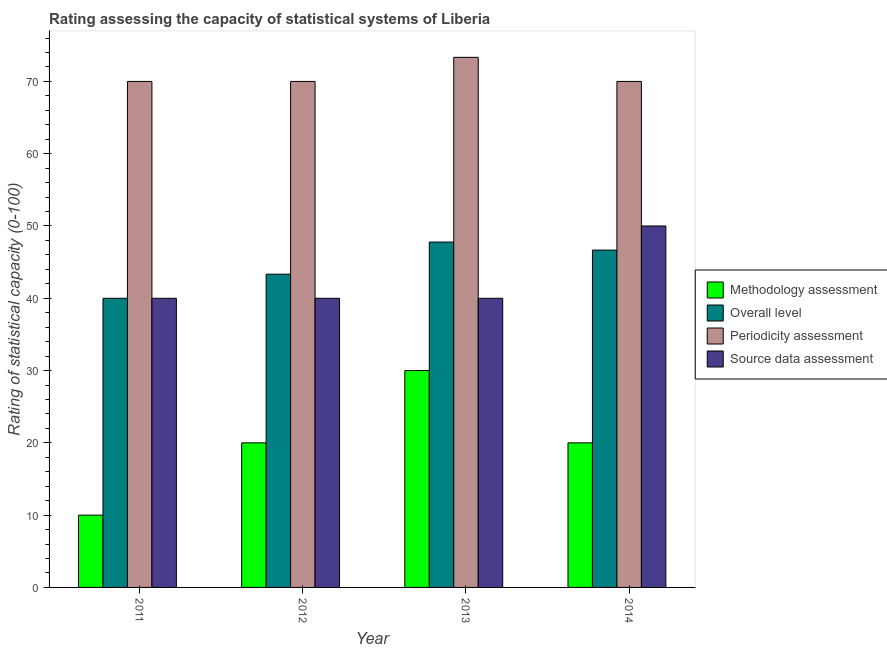How many different coloured bars are there?
Keep it short and to the point. 4. Are the number of bars per tick equal to the number of legend labels?
Keep it short and to the point. Yes. Are the number of bars on each tick of the X-axis equal?
Offer a very short reply. Yes. How many bars are there on the 3rd tick from the left?
Your answer should be very brief. 4. What is the label of the 4th group of bars from the left?
Make the answer very short. 2014. In how many cases, is the number of bars for a given year not equal to the number of legend labels?
Provide a short and direct response. 0. What is the source data assessment rating in 2012?
Your answer should be compact. 40. Across all years, what is the maximum overall level rating?
Keep it short and to the point. 47.78. Across all years, what is the minimum periodicity assessment rating?
Your response must be concise. 70. In which year was the source data assessment rating minimum?
Offer a very short reply. 2011. What is the total periodicity assessment rating in the graph?
Make the answer very short. 283.33. What is the difference between the methodology assessment rating in 2013 and the overall level rating in 2011?
Your answer should be compact. 20. In how many years, is the periodicity assessment rating greater than 6?
Make the answer very short. 4. What is the ratio of the source data assessment rating in 2012 to that in 2013?
Provide a succinct answer. 1. Is the source data assessment rating in 2013 less than that in 2014?
Your response must be concise. Yes. What is the difference between the highest and the second highest methodology assessment rating?
Your answer should be compact. 10. What is the difference between the highest and the lowest methodology assessment rating?
Offer a terse response. 20. In how many years, is the overall level rating greater than the average overall level rating taken over all years?
Provide a short and direct response. 2. Is the sum of the periodicity assessment rating in 2012 and 2014 greater than the maximum source data assessment rating across all years?
Your response must be concise. Yes. Is it the case that in every year, the sum of the source data assessment rating and methodology assessment rating is greater than the sum of periodicity assessment rating and overall level rating?
Provide a short and direct response. No. What does the 4th bar from the left in 2014 represents?
Ensure brevity in your answer.  Source data assessment. What does the 2nd bar from the right in 2012 represents?
Provide a short and direct response. Periodicity assessment. How many bars are there?
Make the answer very short. 16. What is the difference between two consecutive major ticks on the Y-axis?
Offer a terse response. 10. Are the values on the major ticks of Y-axis written in scientific E-notation?
Provide a short and direct response. No. How many legend labels are there?
Ensure brevity in your answer.  4. What is the title of the graph?
Make the answer very short. Rating assessing the capacity of statistical systems of Liberia. Does "Rule based governance" appear as one of the legend labels in the graph?
Provide a succinct answer. No. What is the label or title of the Y-axis?
Keep it short and to the point. Rating of statistical capacity (0-100). What is the Rating of statistical capacity (0-100) of Overall level in 2011?
Make the answer very short. 40. What is the Rating of statistical capacity (0-100) in Periodicity assessment in 2011?
Your response must be concise. 70. What is the Rating of statistical capacity (0-100) of Source data assessment in 2011?
Give a very brief answer. 40. What is the Rating of statistical capacity (0-100) in Overall level in 2012?
Your answer should be very brief. 43.33. What is the Rating of statistical capacity (0-100) of Periodicity assessment in 2012?
Provide a short and direct response. 70. What is the Rating of statistical capacity (0-100) of Overall level in 2013?
Ensure brevity in your answer.  47.78. What is the Rating of statistical capacity (0-100) in Periodicity assessment in 2013?
Make the answer very short. 73.33. What is the Rating of statistical capacity (0-100) of Methodology assessment in 2014?
Make the answer very short. 20. What is the Rating of statistical capacity (0-100) in Overall level in 2014?
Keep it short and to the point. 46.67. Across all years, what is the maximum Rating of statistical capacity (0-100) of Overall level?
Offer a terse response. 47.78. Across all years, what is the maximum Rating of statistical capacity (0-100) in Periodicity assessment?
Give a very brief answer. 73.33. Across all years, what is the minimum Rating of statistical capacity (0-100) in Methodology assessment?
Provide a short and direct response. 10. Across all years, what is the minimum Rating of statistical capacity (0-100) of Overall level?
Offer a very short reply. 40. Across all years, what is the minimum Rating of statistical capacity (0-100) in Periodicity assessment?
Your answer should be compact. 70. What is the total Rating of statistical capacity (0-100) of Methodology assessment in the graph?
Give a very brief answer. 80. What is the total Rating of statistical capacity (0-100) in Overall level in the graph?
Make the answer very short. 177.78. What is the total Rating of statistical capacity (0-100) of Periodicity assessment in the graph?
Give a very brief answer. 283.33. What is the total Rating of statistical capacity (0-100) of Source data assessment in the graph?
Your response must be concise. 170. What is the difference between the Rating of statistical capacity (0-100) in Methodology assessment in 2011 and that in 2012?
Give a very brief answer. -10. What is the difference between the Rating of statistical capacity (0-100) of Overall level in 2011 and that in 2012?
Give a very brief answer. -3.33. What is the difference between the Rating of statistical capacity (0-100) of Source data assessment in 2011 and that in 2012?
Your answer should be compact. 0. What is the difference between the Rating of statistical capacity (0-100) in Overall level in 2011 and that in 2013?
Keep it short and to the point. -7.78. What is the difference between the Rating of statistical capacity (0-100) in Periodicity assessment in 2011 and that in 2013?
Offer a terse response. -3.33. What is the difference between the Rating of statistical capacity (0-100) in Overall level in 2011 and that in 2014?
Offer a terse response. -6.67. What is the difference between the Rating of statistical capacity (0-100) of Overall level in 2012 and that in 2013?
Your response must be concise. -4.44. What is the difference between the Rating of statistical capacity (0-100) of Periodicity assessment in 2012 and that in 2014?
Your answer should be compact. 0. What is the difference between the Rating of statistical capacity (0-100) of Methodology assessment in 2013 and that in 2014?
Keep it short and to the point. 10. What is the difference between the Rating of statistical capacity (0-100) of Overall level in 2013 and that in 2014?
Offer a terse response. 1.11. What is the difference between the Rating of statistical capacity (0-100) in Periodicity assessment in 2013 and that in 2014?
Your answer should be very brief. 3.33. What is the difference between the Rating of statistical capacity (0-100) in Source data assessment in 2013 and that in 2014?
Your response must be concise. -10. What is the difference between the Rating of statistical capacity (0-100) in Methodology assessment in 2011 and the Rating of statistical capacity (0-100) in Overall level in 2012?
Provide a short and direct response. -33.33. What is the difference between the Rating of statistical capacity (0-100) in Methodology assessment in 2011 and the Rating of statistical capacity (0-100) in Periodicity assessment in 2012?
Keep it short and to the point. -60. What is the difference between the Rating of statistical capacity (0-100) of Methodology assessment in 2011 and the Rating of statistical capacity (0-100) of Overall level in 2013?
Give a very brief answer. -37.78. What is the difference between the Rating of statistical capacity (0-100) of Methodology assessment in 2011 and the Rating of statistical capacity (0-100) of Periodicity assessment in 2013?
Ensure brevity in your answer.  -63.33. What is the difference between the Rating of statistical capacity (0-100) in Methodology assessment in 2011 and the Rating of statistical capacity (0-100) in Source data assessment in 2013?
Ensure brevity in your answer.  -30. What is the difference between the Rating of statistical capacity (0-100) in Overall level in 2011 and the Rating of statistical capacity (0-100) in Periodicity assessment in 2013?
Make the answer very short. -33.33. What is the difference between the Rating of statistical capacity (0-100) in Overall level in 2011 and the Rating of statistical capacity (0-100) in Source data assessment in 2013?
Your answer should be compact. 0. What is the difference between the Rating of statistical capacity (0-100) in Methodology assessment in 2011 and the Rating of statistical capacity (0-100) in Overall level in 2014?
Offer a very short reply. -36.67. What is the difference between the Rating of statistical capacity (0-100) of Methodology assessment in 2011 and the Rating of statistical capacity (0-100) of Periodicity assessment in 2014?
Provide a short and direct response. -60. What is the difference between the Rating of statistical capacity (0-100) of Methodology assessment in 2011 and the Rating of statistical capacity (0-100) of Source data assessment in 2014?
Offer a terse response. -40. What is the difference between the Rating of statistical capacity (0-100) of Overall level in 2011 and the Rating of statistical capacity (0-100) of Source data assessment in 2014?
Your response must be concise. -10. What is the difference between the Rating of statistical capacity (0-100) of Periodicity assessment in 2011 and the Rating of statistical capacity (0-100) of Source data assessment in 2014?
Make the answer very short. 20. What is the difference between the Rating of statistical capacity (0-100) in Methodology assessment in 2012 and the Rating of statistical capacity (0-100) in Overall level in 2013?
Your answer should be compact. -27.78. What is the difference between the Rating of statistical capacity (0-100) in Methodology assessment in 2012 and the Rating of statistical capacity (0-100) in Periodicity assessment in 2013?
Ensure brevity in your answer.  -53.33. What is the difference between the Rating of statistical capacity (0-100) in Methodology assessment in 2012 and the Rating of statistical capacity (0-100) in Source data assessment in 2013?
Your answer should be very brief. -20. What is the difference between the Rating of statistical capacity (0-100) in Overall level in 2012 and the Rating of statistical capacity (0-100) in Source data assessment in 2013?
Give a very brief answer. 3.33. What is the difference between the Rating of statistical capacity (0-100) of Periodicity assessment in 2012 and the Rating of statistical capacity (0-100) of Source data assessment in 2013?
Make the answer very short. 30. What is the difference between the Rating of statistical capacity (0-100) in Methodology assessment in 2012 and the Rating of statistical capacity (0-100) in Overall level in 2014?
Provide a succinct answer. -26.67. What is the difference between the Rating of statistical capacity (0-100) in Methodology assessment in 2012 and the Rating of statistical capacity (0-100) in Periodicity assessment in 2014?
Your answer should be very brief. -50. What is the difference between the Rating of statistical capacity (0-100) in Overall level in 2012 and the Rating of statistical capacity (0-100) in Periodicity assessment in 2014?
Give a very brief answer. -26.67. What is the difference between the Rating of statistical capacity (0-100) of Overall level in 2012 and the Rating of statistical capacity (0-100) of Source data assessment in 2014?
Provide a short and direct response. -6.67. What is the difference between the Rating of statistical capacity (0-100) in Methodology assessment in 2013 and the Rating of statistical capacity (0-100) in Overall level in 2014?
Keep it short and to the point. -16.67. What is the difference between the Rating of statistical capacity (0-100) in Methodology assessment in 2013 and the Rating of statistical capacity (0-100) in Periodicity assessment in 2014?
Provide a succinct answer. -40. What is the difference between the Rating of statistical capacity (0-100) in Methodology assessment in 2013 and the Rating of statistical capacity (0-100) in Source data assessment in 2014?
Keep it short and to the point. -20. What is the difference between the Rating of statistical capacity (0-100) of Overall level in 2013 and the Rating of statistical capacity (0-100) of Periodicity assessment in 2014?
Offer a very short reply. -22.22. What is the difference between the Rating of statistical capacity (0-100) in Overall level in 2013 and the Rating of statistical capacity (0-100) in Source data assessment in 2014?
Your answer should be very brief. -2.22. What is the difference between the Rating of statistical capacity (0-100) of Periodicity assessment in 2013 and the Rating of statistical capacity (0-100) of Source data assessment in 2014?
Ensure brevity in your answer.  23.33. What is the average Rating of statistical capacity (0-100) in Overall level per year?
Your answer should be very brief. 44.44. What is the average Rating of statistical capacity (0-100) in Periodicity assessment per year?
Your answer should be very brief. 70.83. What is the average Rating of statistical capacity (0-100) of Source data assessment per year?
Offer a very short reply. 42.5. In the year 2011, what is the difference between the Rating of statistical capacity (0-100) in Methodology assessment and Rating of statistical capacity (0-100) in Periodicity assessment?
Offer a terse response. -60. In the year 2011, what is the difference between the Rating of statistical capacity (0-100) of Methodology assessment and Rating of statistical capacity (0-100) of Source data assessment?
Ensure brevity in your answer.  -30. In the year 2011, what is the difference between the Rating of statistical capacity (0-100) in Overall level and Rating of statistical capacity (0-100) in Source data assessment?
Make the answer very short. 0. In the year 2011, what is the difference between the Rating of statistical capacity (0-100) in Periodicity assessment and Rating of statistical capacity (0-100) in Source data assessment?
Provide a short and direct response. 30. In the year 2012, what is the difference between the Rating of statistical capacity (0-100) in Methodology assessment and Rating of statistical capacity (0-100) in Overall level?
Your answer should be very brief. -23.33. In the year 2012, what is the difference between the Rating of statistical capacity (0-100) in Methodology assessment and Rating of statistical capacity (0-100) in Periodicity assessment?
Provide a succinct answer. -50. In the year 2012, what is the difference between the Rating of statistical capacity (0-100) in Overall level and Rating of statistical capacity (0-100) in Periodicity assessment?
Give a very brief answer. -26.67. In the year 2012, what is the difference between the Rating of statistical capacity (0-100) in Overall level and Rating of statistical capacity (0-100) in Source data assessment?
Keep it short and to the point. 3.33. In the year 2013, what is the difference between the Rating of statistical capacity (0-100) in Methodology assessment and Rating of statistical capacity (0-100) in Overall level?
Make the answer very short. -17.78. In the year 2013, what is the difference between the Rating of statistical capacity (0-100) of Methodology assessment and Rating of statistical capacity (0-100) of Periodicity assessment?
Offer a very short reply. -43.33. In the year 2013, what is the difference between the Rating of statistical capacity (0-100) in Overall level and Rating of statistical capacity (0-100) in Periodicity assessment?
Provide a short and direct response. -25.56. In the year 2013, what is the difference between the Rating of statistical capacity (0-100) of Overall level and Rating of statistical capacity (0-100) of Source data assessment?
Ensure brevity in your answer.  7.78. In the year 2013, what is the difference between the Rating of statistical capacity (0-100) in Periodicity assessment and Rating of statistical capacity (0-100) in Source data assessment?
Your answer should be very brief. 33.33. In the year 2014, what is the difference between the Rating of statistical capacity (0-100) of Methodology assessment and Rating of statistical capacity (0-100) of Overall level?
Your answer should be compact. -26.67. In the year 2014, what is the difference between the Rating of statistical capacity (0-100) of Methodology assessment and Rating of statistical capacity (0-100) of Periodicity assessment?
Offer a terse response. -50. In the year 2014, what is the difference between the Rating of statistical capacity (0-100) in Methodology assessment and Rating of statistical capacity (0-100) in Source data assessment?
Give a very brief answer. -30. In the year 2014, what is the difference between the Rating of statistical capacity (0-100) in Overall level and Rating of statistical capacity (0-100) in Periodicity assessment?
Offer a very short reply. -23.33. In the year 2014, what is the difference between the Rating of statistical capacity (0-100) of Overall level and Rating of statistical capacity (0-100) of Source data assessment?
Your answer should be compact. -3.33. In the year 2014, what is the difference between the Rating of statistical capacity (0-100) in Periodicity assessment and Rating of statistical capacity (0-100) in Source data assessment?
Make the answer very short. 20. What is the ratio of the Rating of statistical capacity (0-100) in Methodology assessment in 2011 to that in 2012?
Give a very brief answer. 0.5. What is the ratio of the Rating of statistical capacity (0-100) of Overall level in 2011 to that in 2012?
Provide a short and direct response. 0.92. What is the ratio of the Rating of statistical capacity (0-100) of Periodicity assessment in 2011 to that in 2012?
Your answer should be very brief. 1. What is the ratio of the Rating of statistical capacity (0-100) of Source data assessment in 2011 to that in 2012?
Your answer should be very brief. 1. What is the ratio of the Rating of statistical capacity (0-100) of Overall level in 2011 to that in 2013?
Offer a very short reply. 0.84. What is the ratio of the Rating of statistical capacity (0-100) in Periodicity assessment in 2011 to that in 2013?
Your answer should be very brief. 0.95. What is the ratio of the Rating of statistical capacity (0-100) in Overall level in 2011 to that in 2014?
Keep it short and to the point. 0.86. What is the ratio of the Rating of statistical capacity (0-100) in Methodology assessment in 2012 to that in 2013?
Your response must be concise. 0.67. What is the ratio of the Rating of statistical capacity (0-100) in Overall level in 2012 to that in 2013?
Your response must be concise. 0.91. What is the ratio of the Rating of statistical capacity (0-100) of Periodicity assessment in 2012 to that in 2013?
Offer a very short reply. 0.95. What is the ratio of the Rating of statistical capacity (0-100) of Methodology assessment in 2012 to that in 2014?
Keep it short and to the point. 1. What is the ratio of the Rating of statistical capacity (0-100) of Source data assessment in 2012 to that in 2014?
Keep it short and to the point. 0.8. What is the ratio of the Rating of statistical capacity (0-100) of Overall level in 2013 to that in 2014?
Offer a terse response. 1.02. What is the ratio of the Rating of statistical capacity (0-100) in Periodicity assessment in 2013 to that in 2014?
Keep it short and to the point. 1.05. What is the difference between the highest and the second highest Rating of statistical capacity (0-100) in Overall level?
Offer a terse response. 1.11. What is the difference between the highest and the second highest Rating of statistical capacity (0-100) of Periodicity assessment?
Offer a terse response. 3.33. What is the difference between the highest and the second highest Rating of statistical capacity (0-100) of Source data assessment?
Offer a terse response. 10. What is the difference between the highest and the lowest Rating of statistical capacity (0-100) in Methodology assessment?
Provide a succinct answer. 20. What is the difference between the highest and the lowest Rating of statistical capacity (0-100) of Overall level?
Keep it short and to the point. 7.78. 